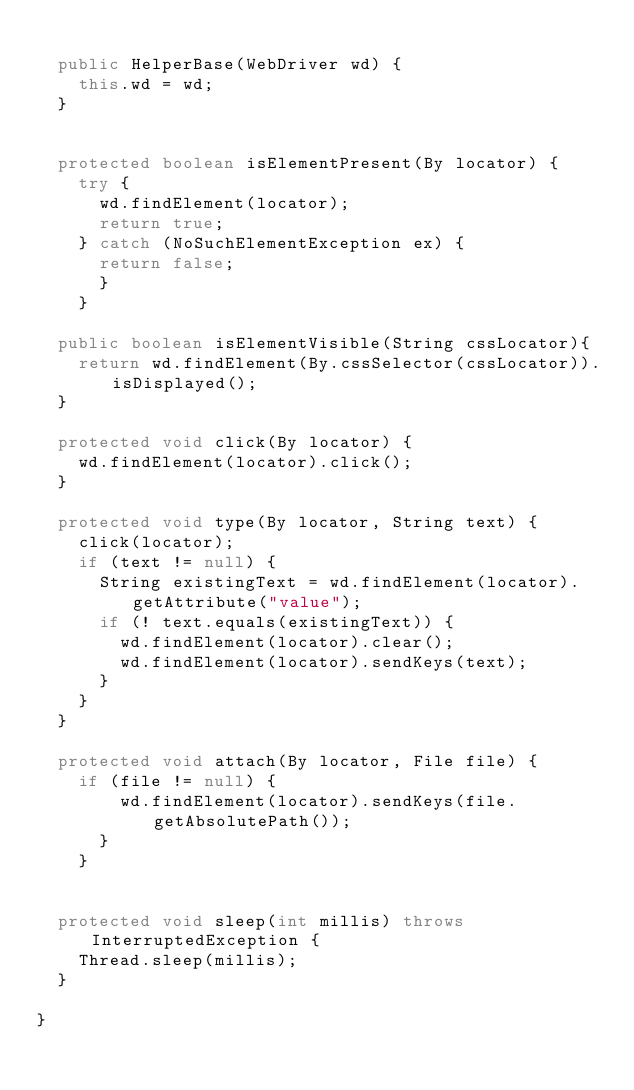<code> <loc_0><loc_0><loc_500><loc_500><_Java_>
  public HelperBase(WebDriver wd) {
    this.wd = wd;
  }


  protected boolean isElementPresent(By locator) {
    try {
      wd.findElement(locator);
      return true;
    } catch (NoSuchElementException ex) {
      return false;
      }
    }

  public boolean isElementVisible(String cssLocator){
    return wd.findElement(By.cssSelector(cssLocator)).isDisplayed();
  }

  protected void click(By locator) {
    wd.findElement(locator).click();
  }

  protected void type(By locator, String text) {
    click(locator);
    if (text != null) {
      String existingText = wd.findElement(locator).getAttribute("value");
      if (! text.equals(existingText)) {
        wd.findElement(locator).clear();
        wd.findElement(locator).sendKeys(text);
      }
    }
  }

  protected void attach(By locator, File file) {
    if (file != null) {
        wd.findElement(locator).sendKeys(file.getAbsolutePath());
      }
    }


  protected void sleep(int millis) throws InterruptedException {
    Thread.sleep(millis);
  }

}
</code> 